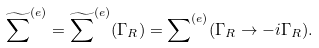Convert formula to latex. <formula><loc_0><loc_0><loc_500><loc_500>\widetilde { \sum } ^ { ( e ) } = \widetilde { \sum } ^ { ( e ) } ( \Gamma _ { R } ) = { \sum } ^ { ( e ) } ( \Gamma _ { R } \rightarrow - i \Gamma _ { R } ) .</formula> 